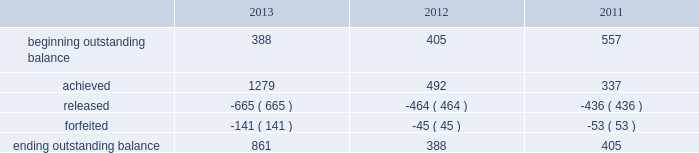Adobe systems incorporated notes to consolidated financial statements ( continued ) in the first quarter of fiscal 2013 , the executive compensation committee certified the actual performance achievement of participants in the 2012 performance share program ( the 201c2012 program 201d ) .
Based upon the achievement of specific and/or market- based performance goals outlined in the 2012 program , participants had the ability to receive up to 150% ( 150 % ) of the target number of shares originally granted .
Actual performance resulted in participants achieving 116% ( 116 % ) of target or approximately 1.3 million shares for the 2012 program .
One third of the shares under the 2012 program vested in the first quarter of fiscal 2013 and the remaining two thirds vest evenly on the following two anniversaries of the grant , contingent upon the recipient's continued service to adobe .
In the first quarter of fiscal 2012 , the executive compensation committee certified the actual performance achievement of participants in the 2011 performance share program ( the 201c2011 program 201d ) .
Based upon the achievement of goals outlined in the 2011 program , participants had the ability to receive up to 150% ( 150 % ) of the target number of shares originally granted .
Actual performance resulted in participants achieving 130% ( 130 % ) of target or approximately 0.5 million shares for the 2011 program .
One third of the shares under the 2011 program vested in the first quarter of fiscal 2012 and the remaining two thirds vest evenly on the following two annual anniversary dates of the grant , contingent upon the recipient's continued service to adobe .
In the first quarter of fiscal 2011 , the executive compensation committee certified the actual performance achievement of participants in the 2010 performance share program ( the 201c2010 program 201d ) .
Based upon the achievement of goals outlined in the 2010 program , participants had the ability to receive up to 150% ( 150 % ) of the target number of shares originally granted .
Actual performance resulted in participants achieving 135% ( 135 % ) of target or approximately 0.3 million shares for the 2010 program .
One third of the shares under the 2011 program vested in the first quarter of fiscal 2012 and the remaining two thirds vest evenly on the following two annual anniversary dates of the grant , contingent upon the recipient's continued service to adobe .
The table sets forth the summary of performance share activity under our 2010 , 2011 and 2012 programs , based upon share awards actually achieved , for the fiscal years ended november 29 , 2013 , november 30 , 2012 and december 2 , 2011 ( in thousands ) : .
The total fair value of performance awards vested during fiscal 2013 , 2012 and 2011 was $ 25.4 million , $ 14.4 million and $ 14.8 million , respectively. .
Based upon the achievement of goals outlined in the 2011 program , what was the difference in percentage points between the maximum % (  % ) of the target number vs . actual performance % (  % ) for the 2011 program? 
Computations: (150 - 130)
Answer: 20.0. 